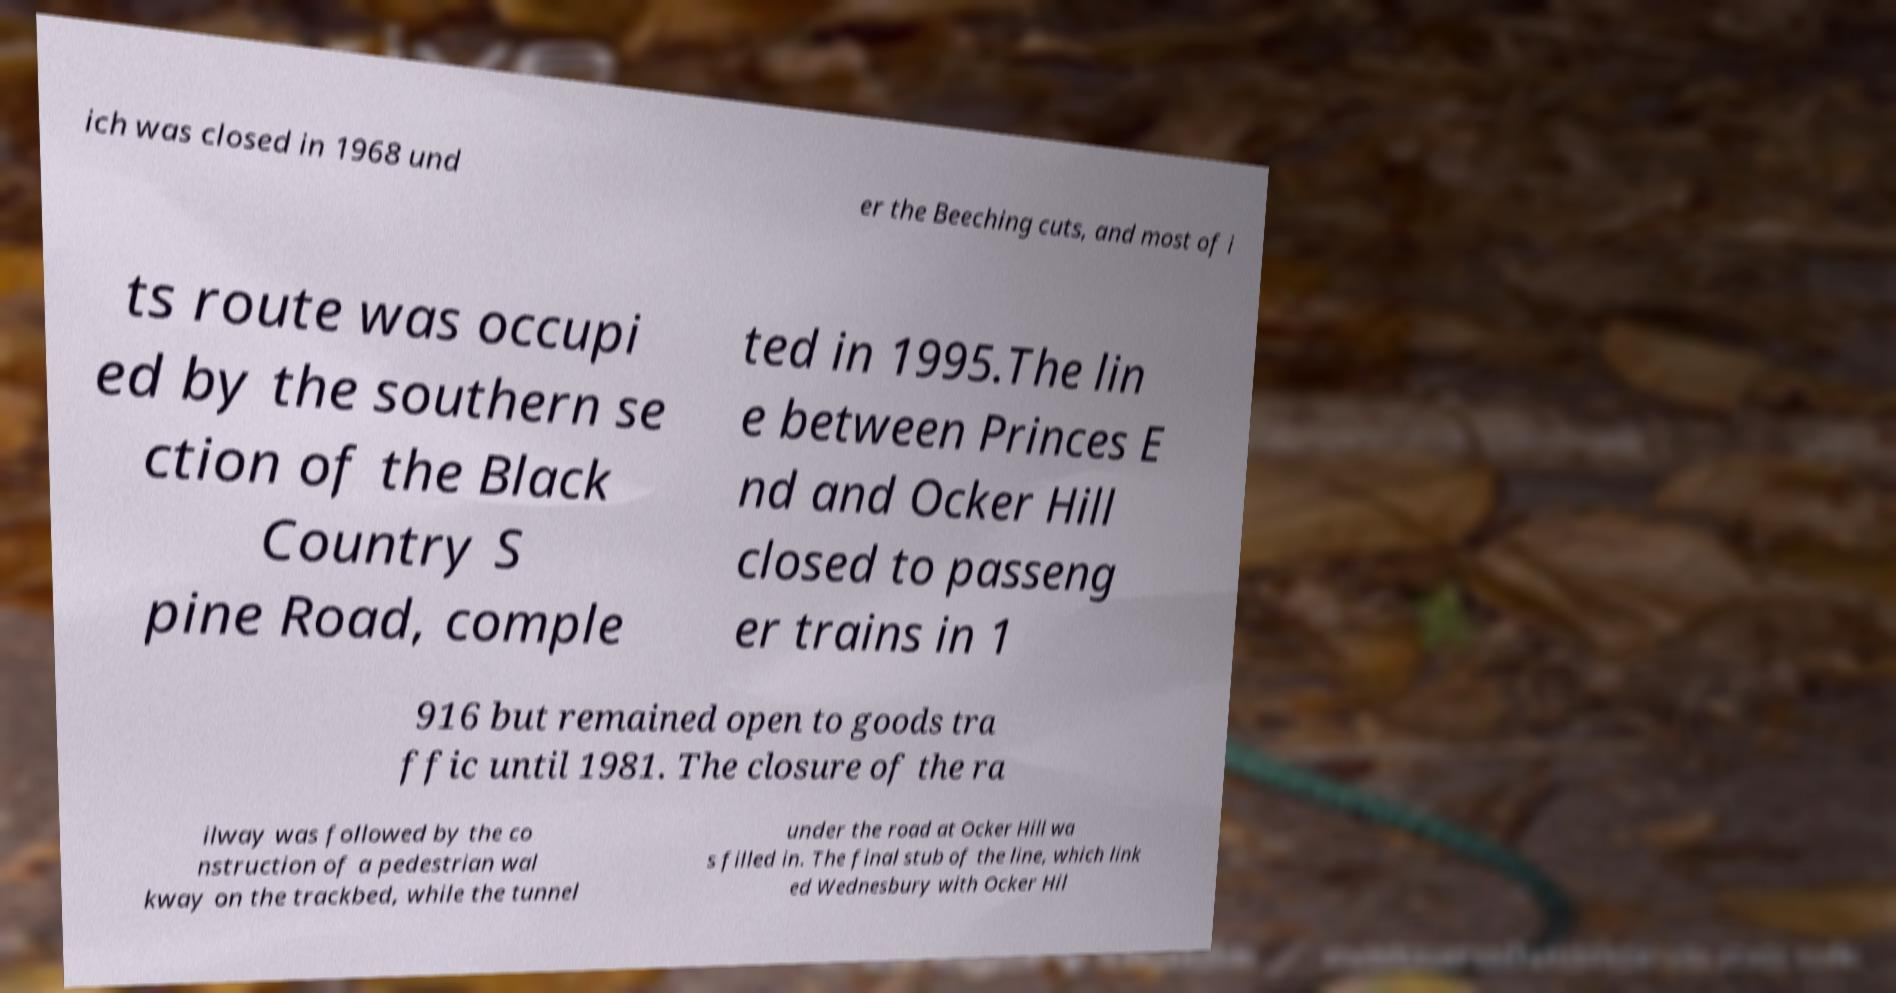For documentation purposes, I need the text within this image transcribed. Could you provide that? ich was closed in 1968 und er the Beeching cuts, and most of i ts route was occupi ed by the southern se ction of the Black Country S pine Road, comple ted in 1995.The lin e between Princes E nd and Ocker Hill closed to passeng er trains in 1 916 but remained open to goods tra ffic until 1981. The closure of the ra ilway was followed by the co nstruction of a pedestrian wal kway on the trackbed, while the tunnel under the road at Ocker Hill wa s filled in. The final stub of the line, which link ed Wednesbury with Ocker Hil 